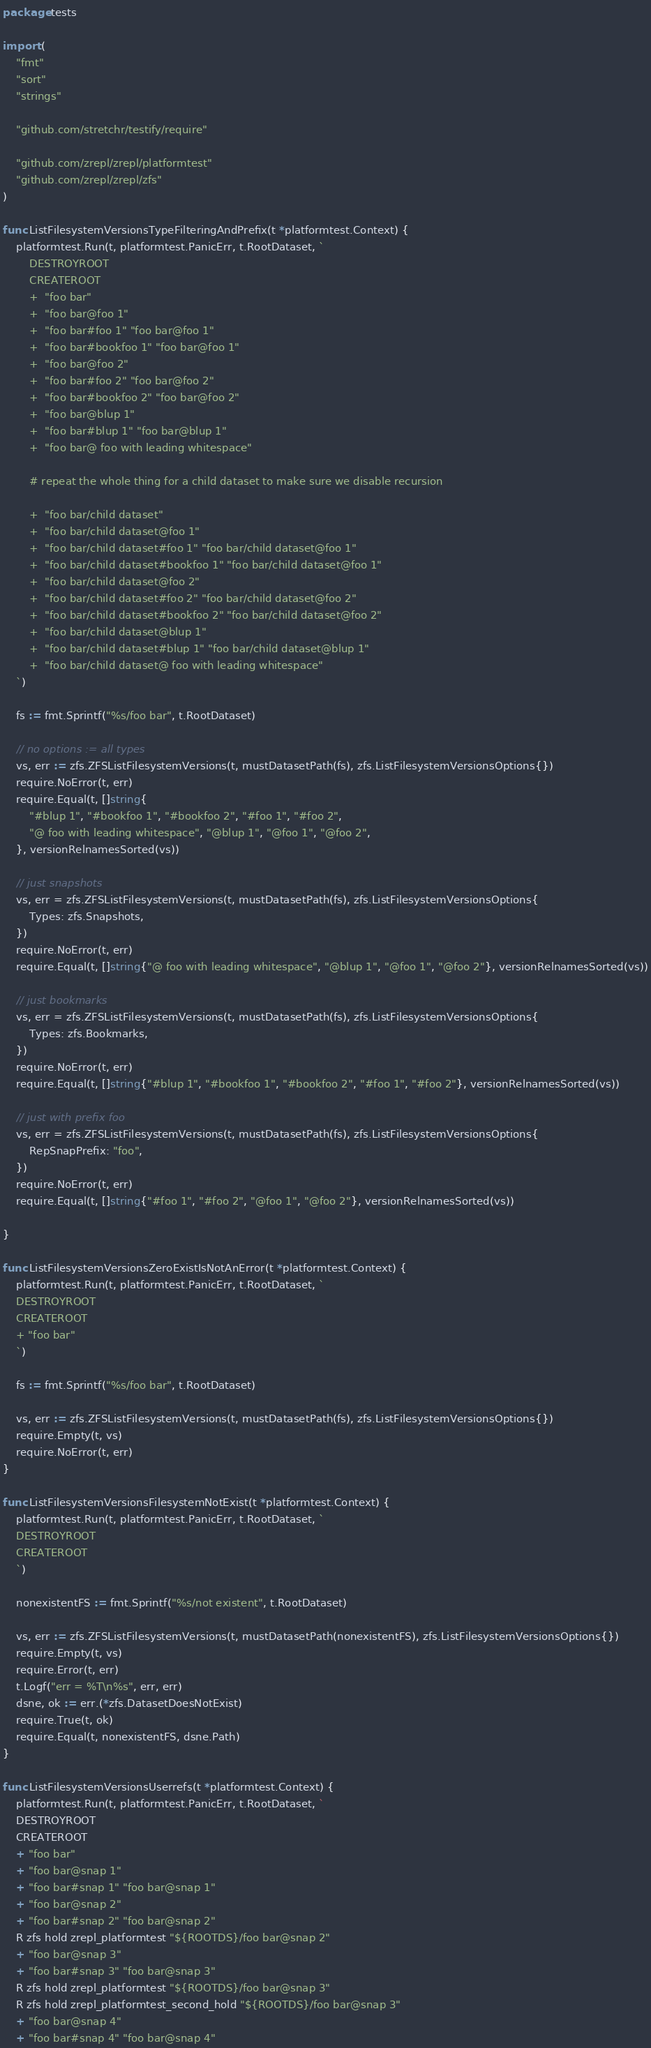Convert code to text. <code><loc_0><loc_0><loc_500><loc_500><_Go_>package tests

import (
	"fmt"
	"sort"
	"strings"

	"github.com/stretchr/testify/require"

	"github.com/zrepl/zrepl/platformtest"
	"github.com/zrepl/zrepl/zfs"
)

func ListFilesystemVersionsTypeFilteringAndPrefix(t *platformtest.Context) {
	platformtest.Run(t, platformtest.PanicErr, t.RootDataset, `
		DESTROYROOT
		CREATEROOT
		+  "foo bar"
		+  "foo bar@foo 1"
		+  "foo bar#foo 1" "foo bar@foo 1"
		+  "foo bar#bookfoo 1" "foo bar@foo 1"
		+  "foo bar@foo 2"
		+  "foo bar#foo 2" "foo bar@foo 2"
		+  "foo bar#bookfoo 2" "foo bar@foo 2"
		+  "foo bar@blup 1"
		+  "foo bar#blup 1" "foo bar@blup 1"
		+  "foo bar@ foo with leading whitespace"

		# repeat the whole thing for a child dataset to make sure we disable recursion

		+  "foo bar/child dataset"
		+  "foo bar/child dataset@foo 1"
		+  "foo bar/child dataset#foo 1" "foo bar/child dataset@foo 1"
		+  "foo bar/child dataset#bookfoo 1" "foo bar/child dataset@foo 1"
		+  "foo bar/child dataset@foo 2"
		+  "foo bar/child dataset#foo 2" "foo bar/child dataset@foo 2"
		+  "foo bar/child dataset#bookfoo 2" "foo bar/child dataset@foo 2"
		+  "foo bar/child dataset@blup 1"
		+  "foo bar/child dataset#blup 1" "foo bar/child dataset@blup 1"
		+  "foo bar/child dataset@ foo with leading whitespace"
	`)

	fs := fmt.Sprintf("%s/foo bar", t.RootDataset)

	// no options := all types
	vs, err := zfs.ZFSListFilesystemVersions(t, mustDatasetPath(fs), zfs.ListFilesystemVersionsOptions{})
	require.NoError(t, err)
	require.Equal(t, []string{
		"#blup 1", "#bookfoo 1", "#bookfoo 2", "#foo 1", "#foo 2",
		"@ foo with leading whitespace", "@blup 1", "@foo 1", "@foo 2",
	}, versionRelnamesSorted(vs))

	// just snapshots
	vs, err = zfs.ZFSListFilesystemVersions(t, mustDatasetPath(fs), zfs.ListFilesystemVersionsOptions{
		Types: zfs.Snapshots,
	})
	require.NoError(t, err)
	require.Equal(t, []string{"@ foo with leading whitespace", "@blup 1", "@foo 1", "@foo 2"}, versionRelnamesSorted(vs))

	// just bookmarks
	vs, err = zfs.ZFSListFilesystemVersions(t, mustDatasetPath(fs), zfs.ListFilesystemVersionsOptions{
		Types: zfs.Bookmarks,
	})
	require.NoError(t, err)
	require.Equal(t, []string{"#blup 1", "#bookfoo 1", "#bookfoo 2", "#foo 1", "#foo 2"}, versionRelnamesSorted(vs))

	// just with prefix foo
	vs, err = zfs.ZFSListFilesystemVersions(t, mustDatasetPath(fs), zfs.ListFilesystemVersionsOptions{
		RepSnapPrefix: "foo",
	})
	require.NoError(t, err)
	require.Equal(t, []string{"#foo 1", "#foo 2", "@foo 1", "@foo 2"}, versionRelnamesSorted(vs))

}

func ListFilesystemVersionsZeroExistIsNotAnError(t *platformtest.Context) {
	platformtest.Run(t, platformtest.PanicErr, t.RootDataset, `
	DESTROYROOT
	CREATEROOT
	+ "foo bar"
	`)

	fs := fmt.Sprintf("%s/foo bar", t.RootDataset)

	vs, err := zfs.ZFSListFilesystemVersions(t, mustDatasetPath(fs), zfs.ListFilesystemVersionsOptions{})
	require.Empty(t, vs)
	require.NoError(t, err)
}

func ListFilesystemVersionsFilesystemNotExist(t *platformtest.Context) {
	platformtest.Run(t, platformtest.PanicErr, t.RootDataset, `
	DESTROYROOT
	CREATEROOT
	`)

	nonexistentFS := fmt.Sprintf("%s/not existent", t.RootDataset)

	vs, err := zfs.ZFSListFilesystemVersions(t, mustDatasetPath(nonexistentFS), zfs.ListFilesystemVersionsOptions{})
	require.Empty(t, vs)
	require.Error(t, err)
	t.Logf("err = %T\n%s", err, err)
	dsne, ok := err.(*zfs.DatasetDoesNotExist)
	require.True(t, ok)
	require.Equal(t, nonexistentFS, dsne.Path)
}

func ListFilesystemVersionsUserrefs(t *platformtest.Context) {
	platformtest.Run(t, platformtest.PanicErr, t.RootDataset, `
	DESTROYROOT
	CREATEROOT
	+ "foo bar"
	+ "foo bar@snap 1"
	+ "foo bar#snap 1" "foo bar@snap 1"
	+ "foo bar@snap 2"
	+ "foo bar#snap 2" "foo bar@snap 2"
	R zfs hold zrepl_platformtest "${ROOTDS}/foo bar@snap 2"
	+ "foo bar@snap 3"
	+ "foo bar#snap 3" "foo bar@snap 3"
	R zfs hold zrepl_platformtest "${ROOTDS}/foo bar@snap 3"
	R zfs hold zrepl_platformtest_second_hold "${ROOTDS}/foo bar@snap 3"
	+ "foo bar@snap 4"
	+ "foo bar#snap 4" "foo bar@snap 4"

</code> 